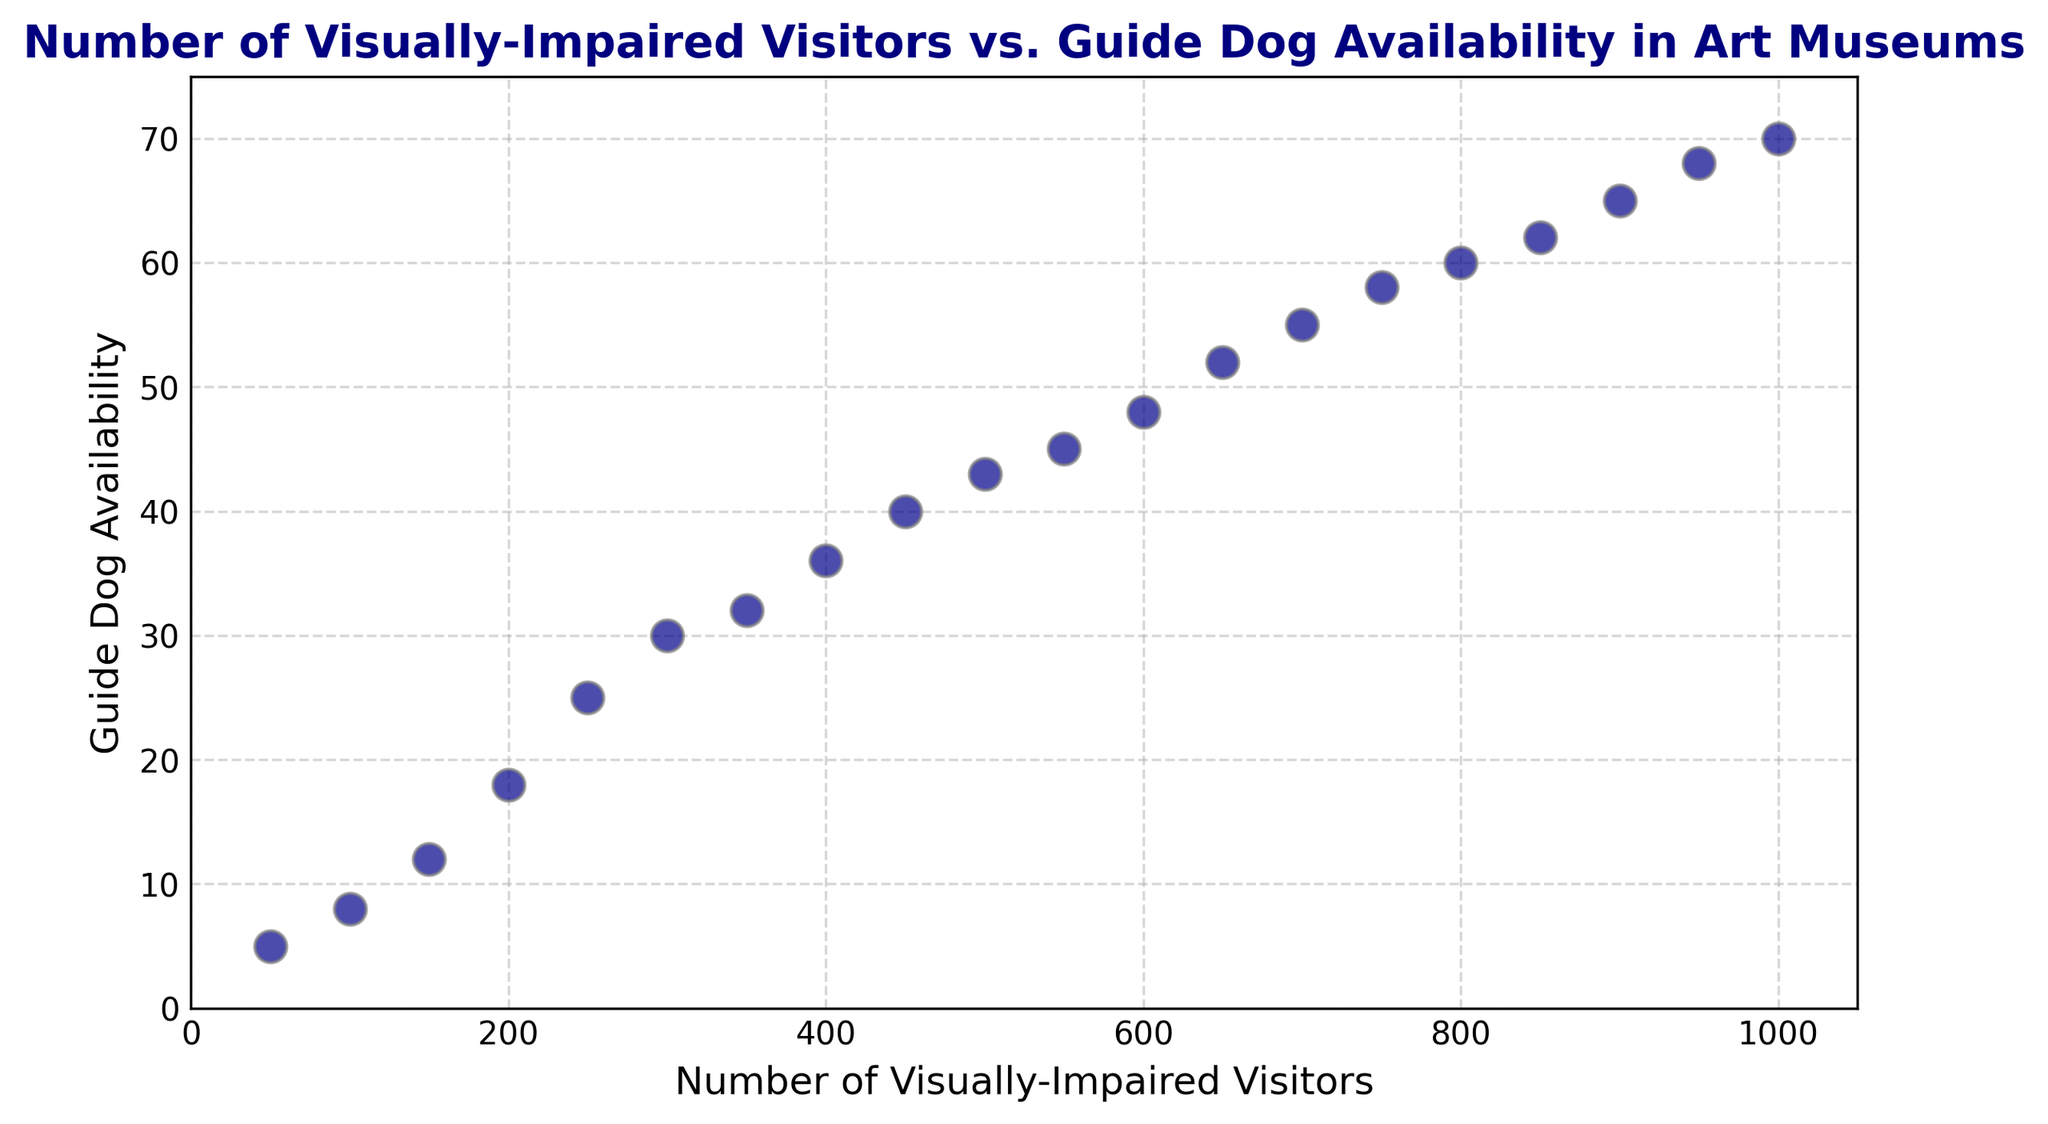What is the number of visually-impaired visitors when the guide dog availability is 36? Locate the point on the scatter plot where the guide dog availability is 36. The corresponding x-coordinate, representing the number of visually-impaired visitors, is 400.
Answer: 400 How many more guide dogs are available at 500 visitors compared to 250 visitors? Identify the guide dog availability for both 500 visitors (43 dogs) and 250 visitors (25 dogs). The difference is 43 - 25 = 18.
Answer: 18 What is the average guide dog availability for 300, 600, and 900 visitors? Locate the guide dog availability for 300 (30 dogs), 600 (48 dogs), and 900 visitors (65 dogs). Calculate the sum and divide by 3: (30 + 48 + 65) / 3 = 47.67.
Answer: 47.67 Which has a higher guide dog availability: 800 visitors or 850 visitors? Compare the guide dog availability for 800 visitors (60 dogs) and 850 visitors (62 dogs). Since 62 is greater than 60, 850 visitors have a higher availability.
Answer: 850 visitors Is there a linear trend between the number of visually-impaired visitors and guide dog availability? Observe the scatter plot: the points lie closely along a straight line, indicating a linear trend between the number of visitors and guide dog availability.
Answer: Yes At what number of visually-impaired visitors does guide dog availability exceed 50? Identify points where the y-coordinate (guide dog availability) is greater than 50. The first such point is at 650 visitors (52 dogs).
Answer: 650 If the number of visually-impaired visitors doubles from 450 to 900, how much does guide dog availability increase? Determine the guide dog availability at 450 visitors (40 dogs) and 900 visitors (65 dogs). The increase is 65 - 40 = 25.
Answer: 25 What are the median values of both visually-impaired visitors and guide dog availability? List the sorted values for visitors (50, 100, 150, ..., 1000) and guide dog availability (5, 8, 12, ..., 70). Both lists have 20 values, so the medians are the average of the 10th and 11th values. Visitors: (500 + 550) / 2 = 525; Guide dogs: (43 + 45) / 2 = 44.
Answer: Visitors: 525, Guide dogs: 44 How does the grid appearance enhance the understanding of the data points? The grid lines, shown in a dashed style, provide visual references that make it easier to compare and measure the coordinates of the data points accurately.
Answer: Enhanced comparability and accuracy 